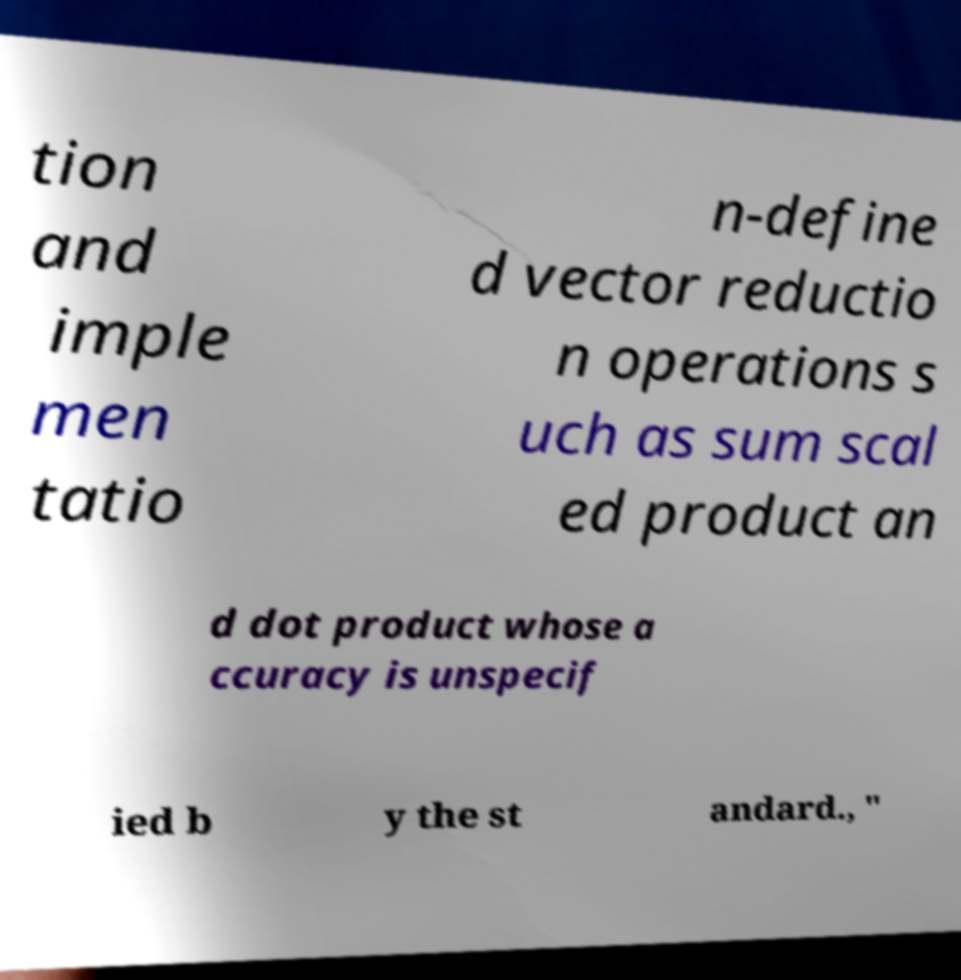For documentation purposes, I need the text within this image transcribed. Could you provide that? tion and imple men tatio n-define d vector reductio n operations s uch as sum scal ed product an d dot product whose a ccuracy is unspecif ied b y the st andard., " 